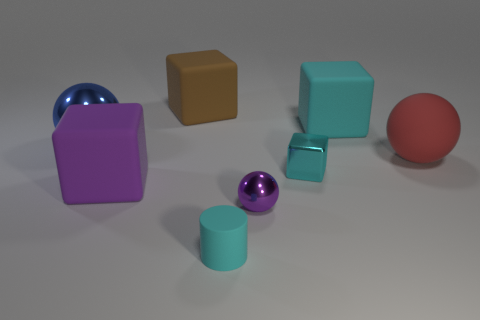The small metallic block is what color?
Provide a succinct answer. Cyan. What material is the sphere that is both behind the small metallic cube and left of the large cyan rubber object?
Ensure brevity in your answer.  Metal. There is a cyan rubber object in front of the small metallic object that is on the right side of the purple metallic object; is there a purple matte thing to the left of it?
Make the answer very short. Yes. There is another rubber cube that is the same color as the tiny block; what is its size?
Your response must be concise. Large. There is a purple cube; are there any balls behind it?
Offer a very short reply. Yes. What number of other objects are the same shape as the large purple rubber object?
Keep it short and to the point. 3. There is a rubber sphere that is the same size as the purple block; what is its color?
Give a very brief answer. Red. Are there fewer small rubber objects to the left of the large blue metal thing than cyan things left of the tiny metal sphere?
Make the answer very short. Yes. What number of things are to the right of the rubber block that is in front of the metal sphere that is behind the big red rubber object?
Offer a terse response. 6. There is a shiny thing that is the same shape as the big brown matte thing; what size is it?
Your answer should be very brief. Small. 